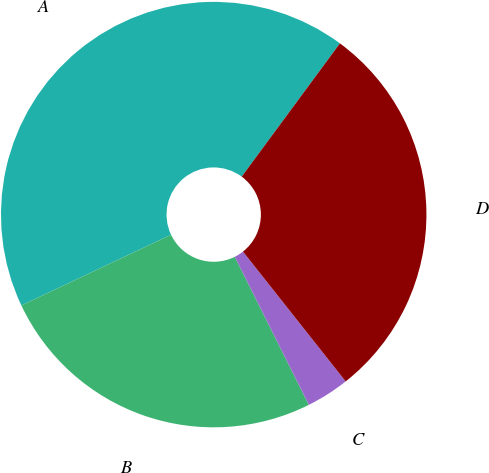<chart> <loc_0><loc_0><loc_500><loc_500><pie_chart><fcel>A<fcel>B<fcel>C<fcel>D<nl><fcel>42.13%<fcel>25.36%<fcel>3.27%<fcel>29.24%<nl></chart> 